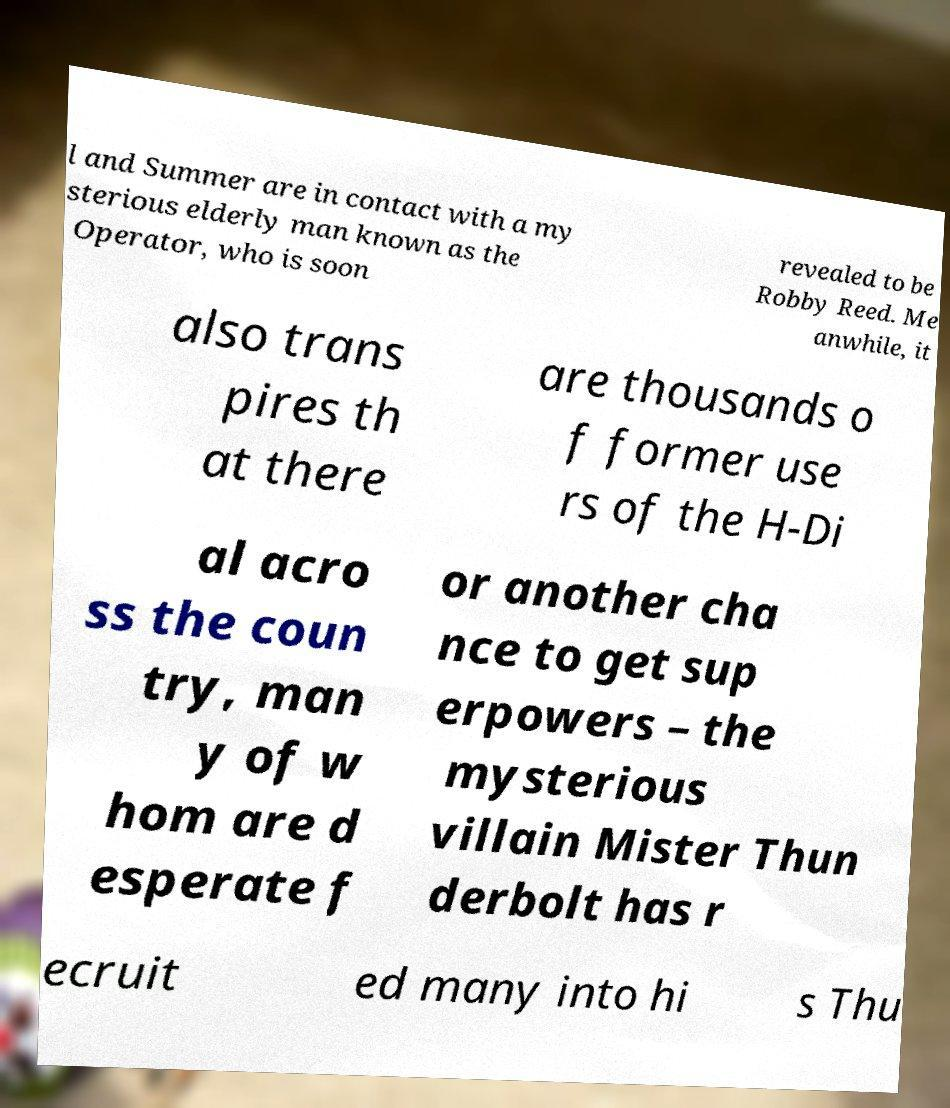Can you accurately transcribe the text from the provided image for me? l and Summer are in contact with a my sterious elderly man known as the Operator, who is soon revealed to be Robby Reed. Me anwhile, it also trans pires th at there are thousands o f former use rs of the H-Di al acro ss the coun try, man y of w hom are d esperate f or another cha nce to get sup erpowers – the mysterious villain Mister Thun derbolt has r ecruit ed many into hi s Thu 